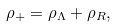Convert formula to latex. <formula><loc_0><loc_0><loc_500><loc_500>\rho _ { + } = \rho _ { \Lambda } + \rho _ { R } ,</formula> 